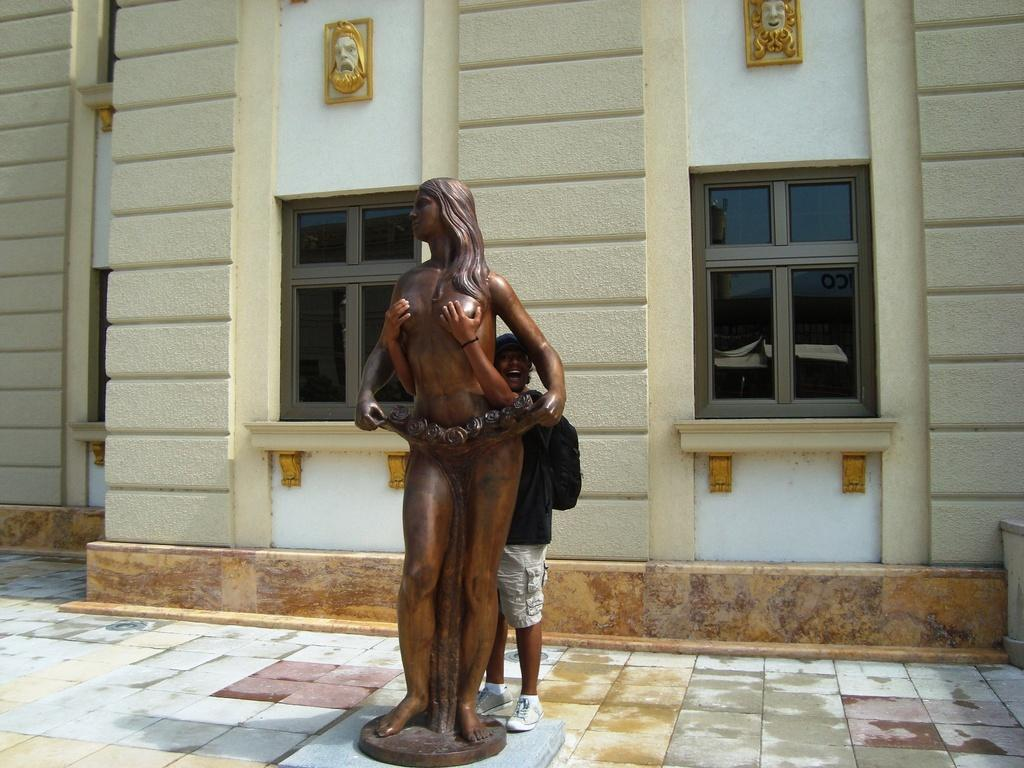What is the main subject of the image? There is a bronze sculpture in the image. Can you describe the person behind the sculpture? The person is not the main focus of the image, but they are visible behind the sculpture. What can be seen on the wall in the image? The wall has windows and designs visible in the image. What color is the mask that the person is wearing in the image? There is no mask present in the image, and the person is not the main focus of the conversation. 